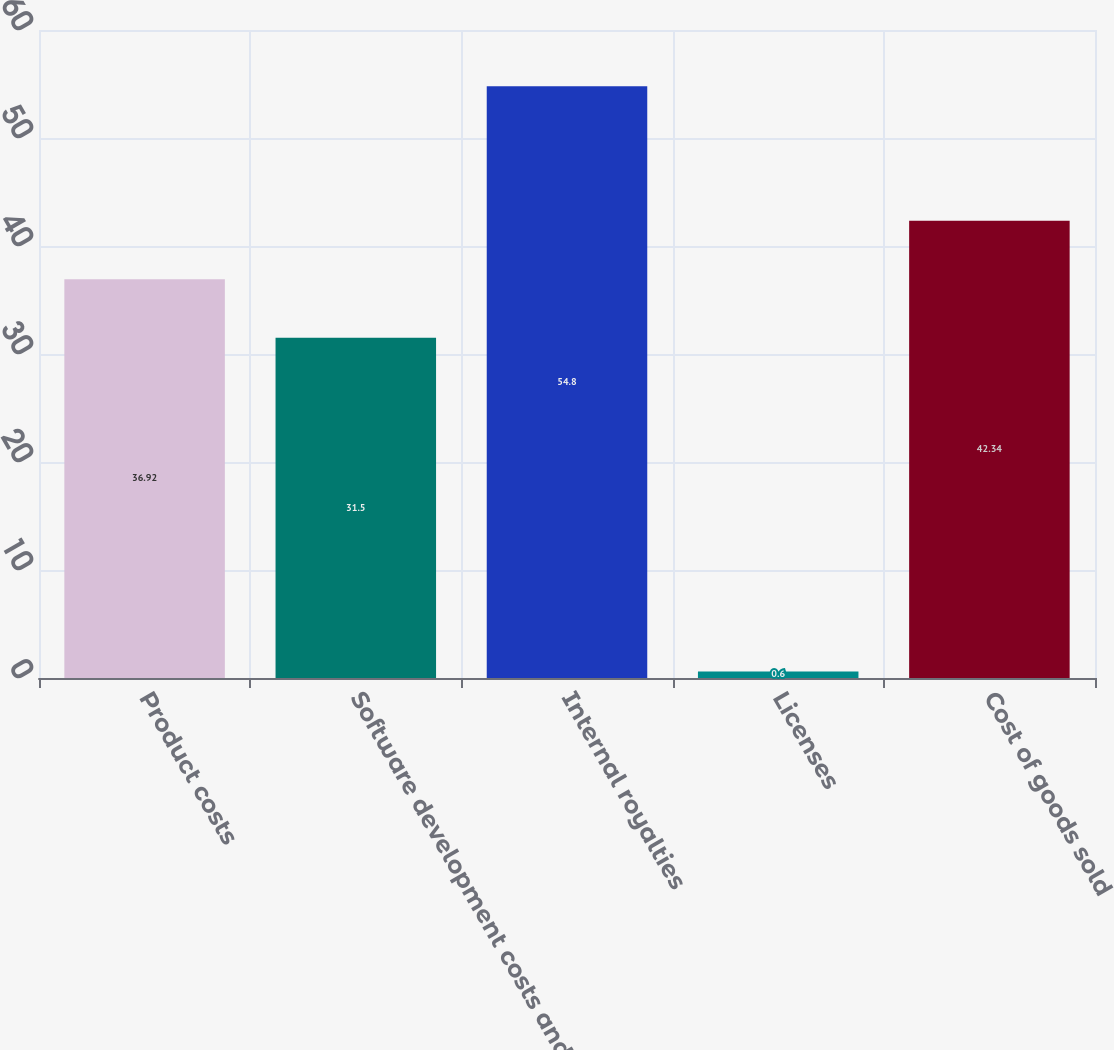Convert chart. <chart><loc_0><loc_0><loc_500><loc_500><bar_chart><fcel>Product costs<fcel>Software development costs and<fcel>Internal royalties<fcel>Licenses<fcel>Cost of goods sold<nl><fcel>36.92<fcel>31.5<fcel>54.8<fcel>0.6<fcel>42.34<nl></chart> 